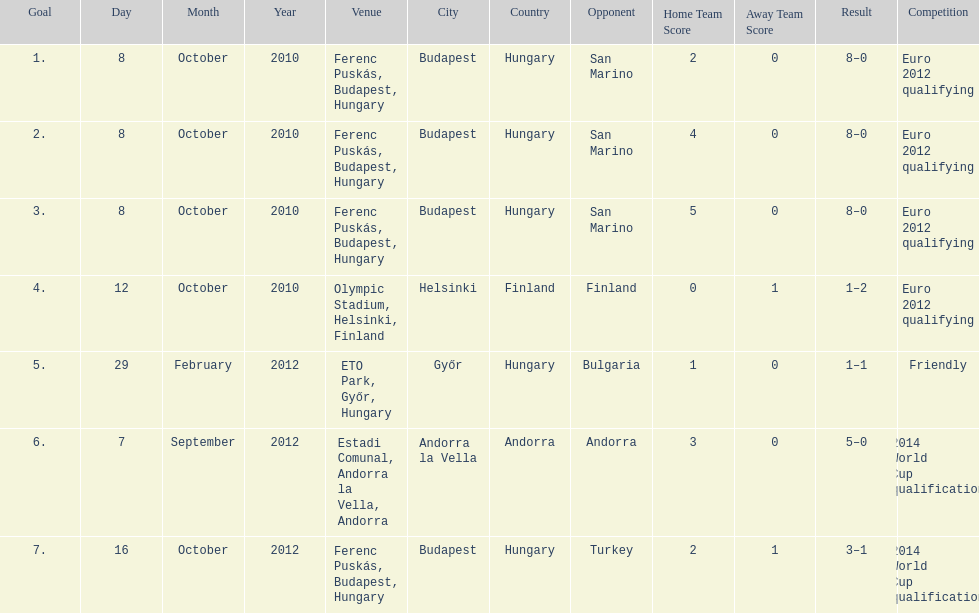In what year was szalai's first international goal? 2010. 